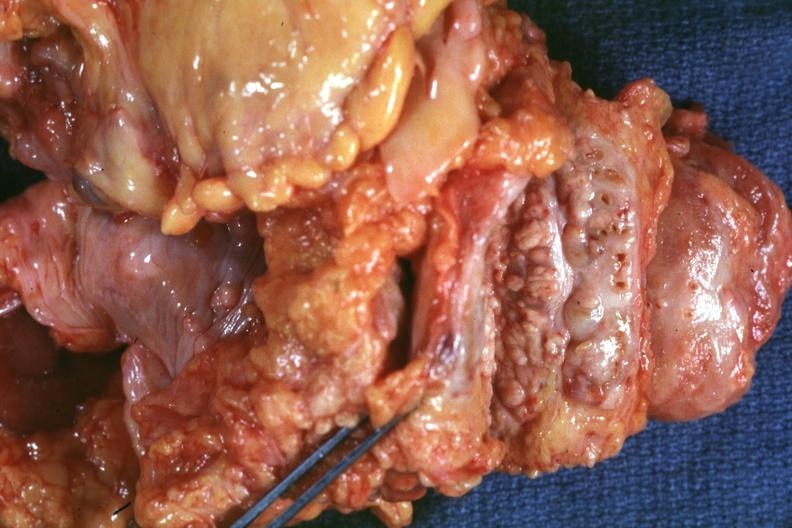what is nodular parenchyma and dense intervening?
Answer the question using a single word or phrase. Tumor tissue very good 